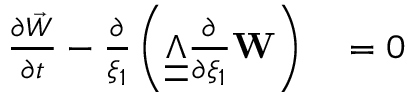Convert formula to latex. <formula><loc_0><loc_0><loc_500><loc_500>\begin{array} { r l } { \frac { \partial \vec { W } } { \partial t } - \frac { \partial } { \xi _ { 1 } } \left ( \underline { { \underline { \boldsymbol \Lambda } } } \frac { \partial } { \partial \xi _ { 1 } } W \right ) } & = 0 } \end{array}</formula> 